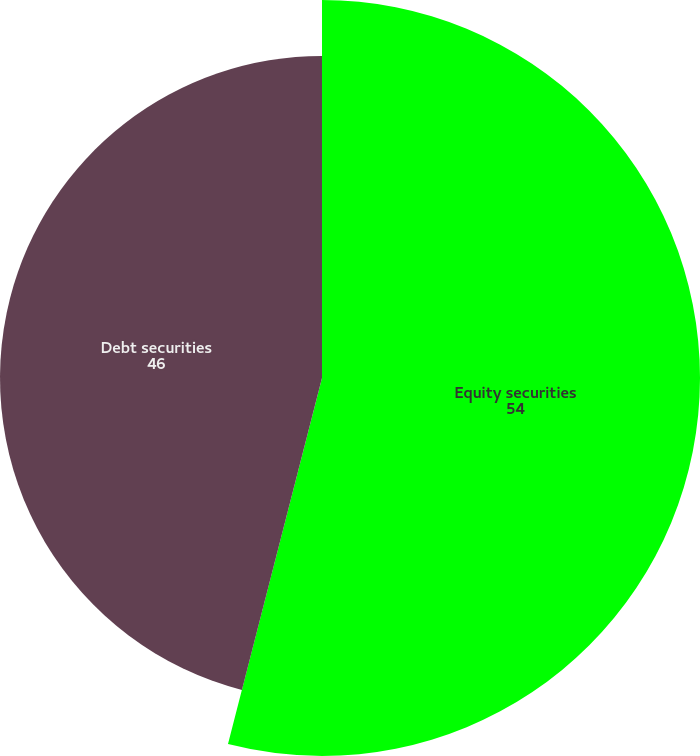<chart> <loc_0><loc_0><loc_500><loc_500><pie_chart><fcel>Equity securities<fcel>Debt securities<nl><fcel>54.0%<fcel>46.0%<nl></chart> 